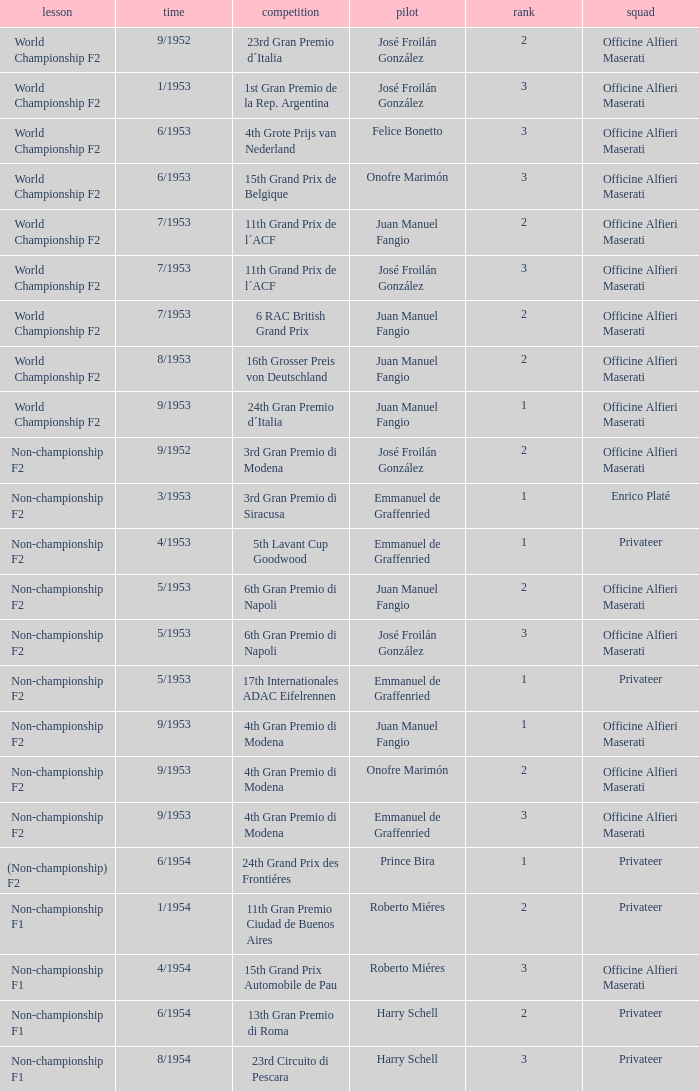What class has the date of 8/1954? Non-championship F1. 